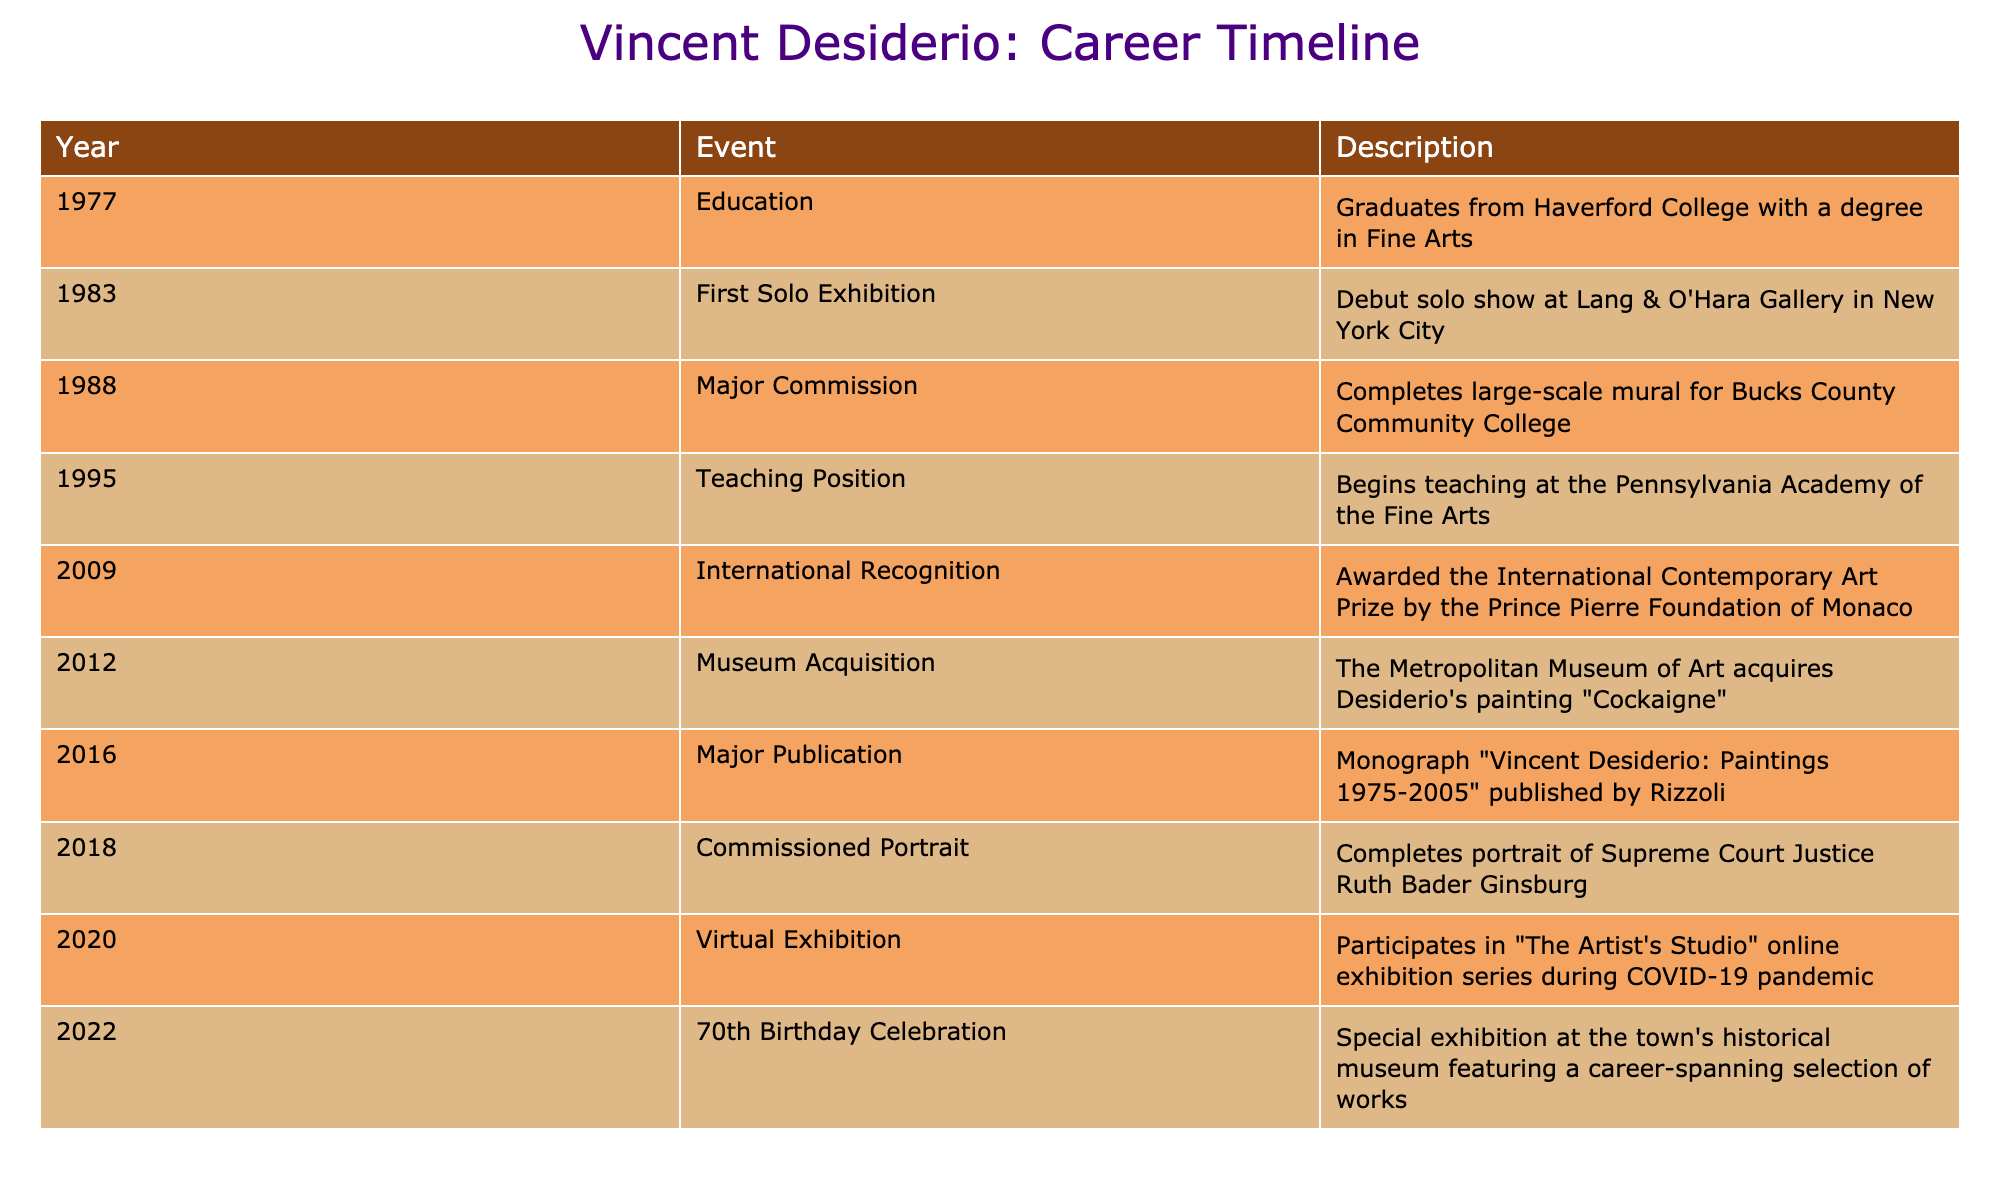What year did the artist graduate from Haverford College? According to the table, the artist graduated from Haverford College in 1977. This information is found in the first row under the Year column and aligns with the Education event.
Answer: 1977 What significant event occurred in 2009? The significant event that occurred in 2009, according to the table, is the artist being awarded the International Contemporary Art Prize by the Prince Pierre Foundation of Monaco. This is listed in the appropriate row under the Event and Description columns.
Answer: International recognition award How many years are there between the first solo exhibition and the major publication? The first solo exhibition took place in 1983 and the major publication was in 2016. To find the number of years between these two events, subtract 1983 from 2016: 2016 - 1983 = 33 years. This is a direct calculation using the values from the Year column for both events.
Answer: 33 years Did the artist complete a major commission before starting a teaching position? Yes, the artist completed a major commission in 1988 and began teaching in 1995. This is confirmed by checking the years associated with both events—the major commission occurred earlier, thus validating the statement.
Answer: Yes What is the total number of events listed between the first solo exhibition and the 70th birthday celebration? There are six events listed between the first solo exhibition in 1983 and the 70th birthday celebration in 2022. These events are: Major Commission (1988), Teaching Position (1995), International Recognition (2009), Museum Acquisition (2012), Major Publication (2016), and Commissioned Portrait (2018). Counting these gives a total of six events.
Answer: 6 events How many years did the artist spend teaching at the Pennsylvania Academy of the Fine Arts before receiving international recognition? The artist began teaching at the Pennsylvania Academy of the Fine Arts in 1995 and received international recognition in 2009. To calculate the number of years spent teaching, subtract 1995 from 2009: 2009 - 1995 = 14 years. This shows how long the artist held that position until gaining recognition.
Answer: 14 years 